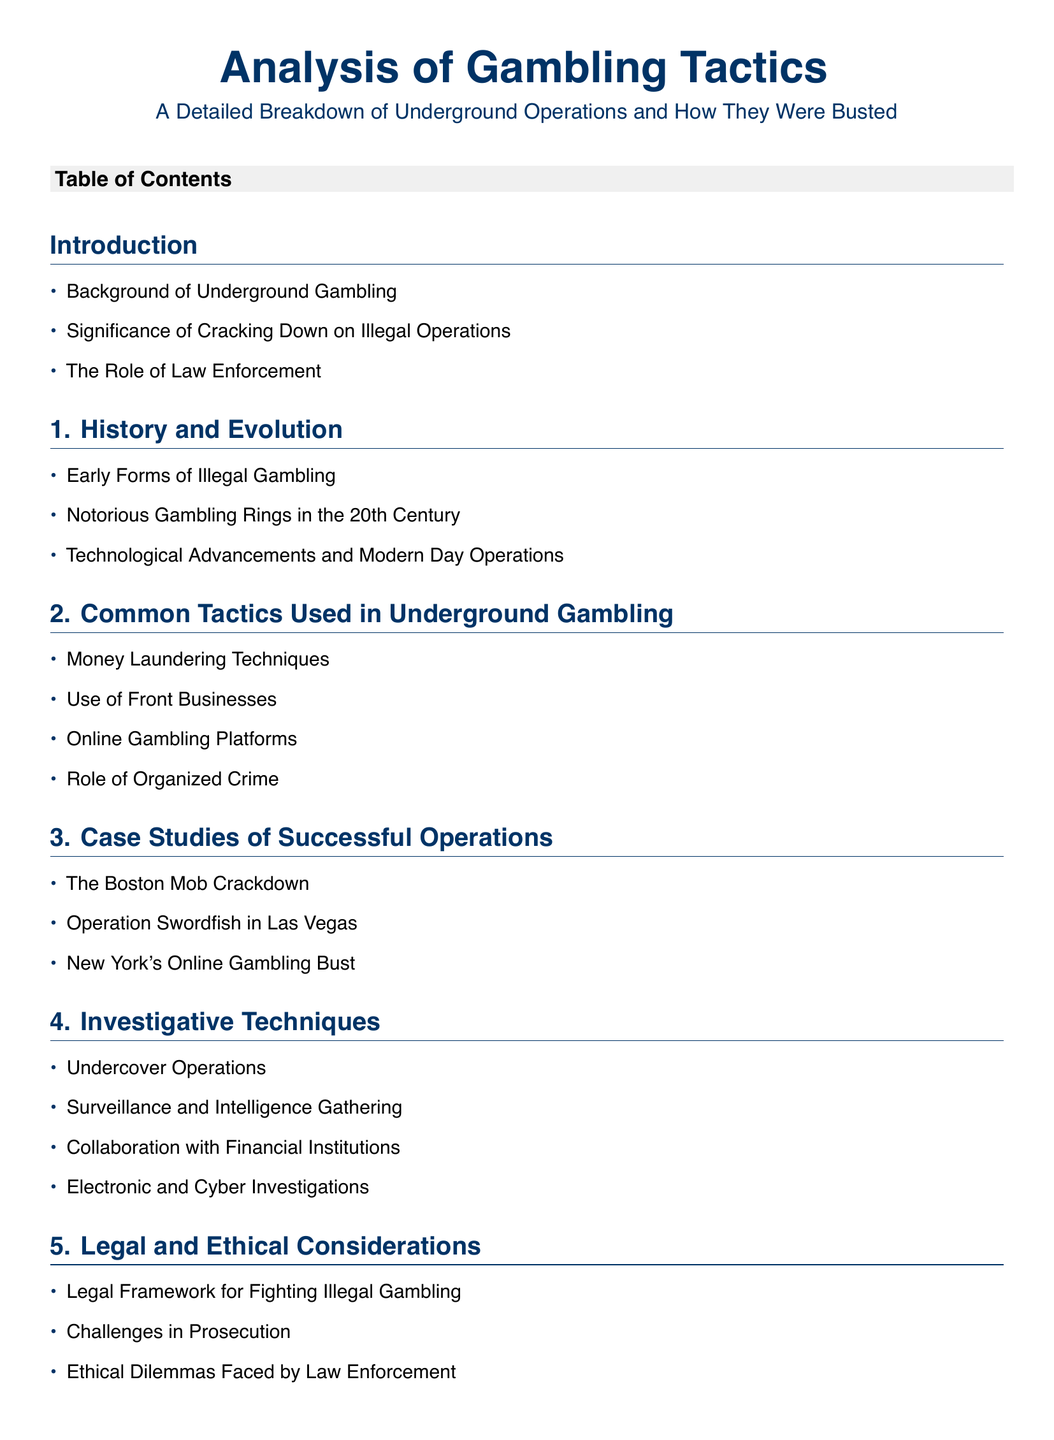What are the early forms of illegal gambling? The section 1 mentions early forms of illegal gambling, which might include activities like underground bookmaking or unregulated dice games.
Answer: Early forms of illegal gambling What operation is associated with the Boston Mob? The case study section lists The Boston Mob Crackdown as a significant operation against underground gambling.
Answer: The Boston Mob Crackdown Which tactic involves disguising illegal credit transactions? In section 2, money laundering techniques are a common tactic used in underground gambling, often involving disguises for illegal transactions.
Answer: Money Laundering Techniques What is a benefit of collaboration with financial institutions? In section 4, the collaboration with financial institutions can enhance investigative techniques to track illicit funds.
Answer: Enhanced tracking of illicit funds What is the significance of the legal framework? Section 5 discusses the legal framework as critical for implementing strategies against illegal gambling operations.
Answer: Critical for implementing strategies How many case studies are detailed in the document? The case studies section includes three distinct cases highlighting successful operations against underground gambling.
Answer: Three What is addressed in the conclusion regarding future enforcement? The conclusion section discusses the future outlook for gambling enforcement, summarizing key insights and recommendations.
Answer: Future outlook for gambling enforcement What are the social implications of busting operations? Section 6 mentions social and community impacts resulting from actions taken against underground gambling operations.
Answer: Social and community impact What type of operations are discussed under investigative techniques? The section 4 outlines undercover operations as a strategy used to infiltrate and investigate illegal gambling activities.
Answer: Undercover Operations 